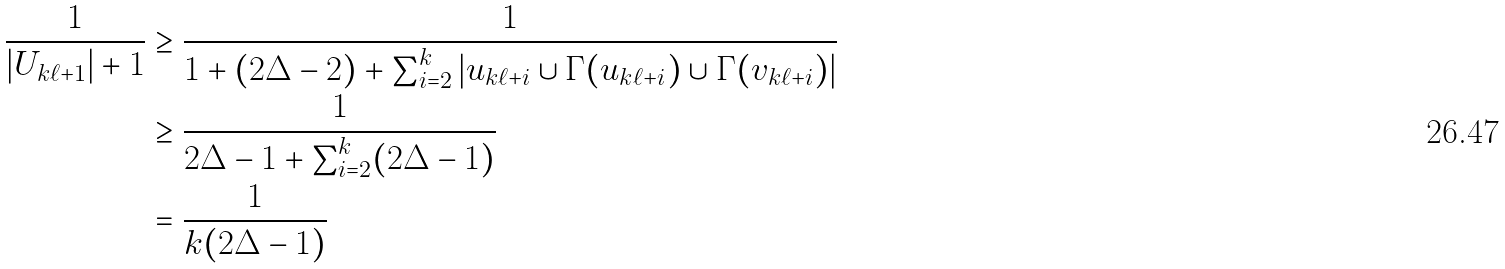<formula> <loc_0><loc_0><loc_500><loc_500>\frac { 1 } { | U _ { k \ell + 1 } | + 1 } & \geq \frac { 1 } { 1 + ( 2 \Delta - 2 ) + \sum _ { i = 2 } ^ { k } | u _ { k \ell + i } \cup \Gamma ( u _ { k \ell + i } ) \cup \Gamma ( v _ { k \ell + i } ) | } \\ & \geq \frac { 1 } { 2 \Delta - 1 + \sum _ { i = 2 } ^ { k } ( 2 \Delta - 1 ) } \\ & = \frac { 1 } { k ( 2 \Delta - 1 ) }</formula> 